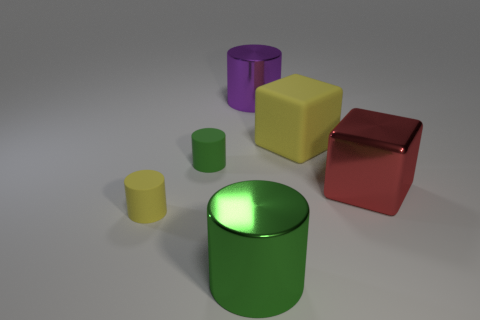What number of other yellow blocks are the same size as the metal cube?
Offer a very short reply. 1. Are there fewer yellow cylinders in front of the small yellow cylinder than big metallic things on the right side of the large purple cylinder?
Keep it short and to the point. Yes. There is a yellow rubber thing behind the yellow matte thing left of the shiny cylinder behind the large green cylinder; what is its size?
Your answer should be compact. Large. There is a matte object that is both behind the metal cube and left of the large purple metal thing; how big is it?
Provide a succinct answer. Small. The green thing that is behind the big cube that is in front of the rubber block is what shape?
Make the answer very short. Cylinder. Is there any other thing that has the same color as the large rubber thing?
Provide a succinct answer. Yes. There is a metal thing in front of the red cube; what is its shape?
Your answer should be very brief. Cylinder. There is a large object that is on the right side of the big purple cylinder and in front of the matte block; what shape is it?
Offer a very short reply. Cube. What number of cyan things are either tiny rubber cylinders or large cubes?
Your answer should be very brief. 0. Do the metal cylinder left of the large purple cylinder and the matte block have the same color?
Your answer should be very brief. No. 